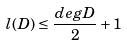<formula> <loc_0><loc_0><loc_500><loc_500>l ( D ) \leq \frac { d e g D } { 2 } + 1</formula> 